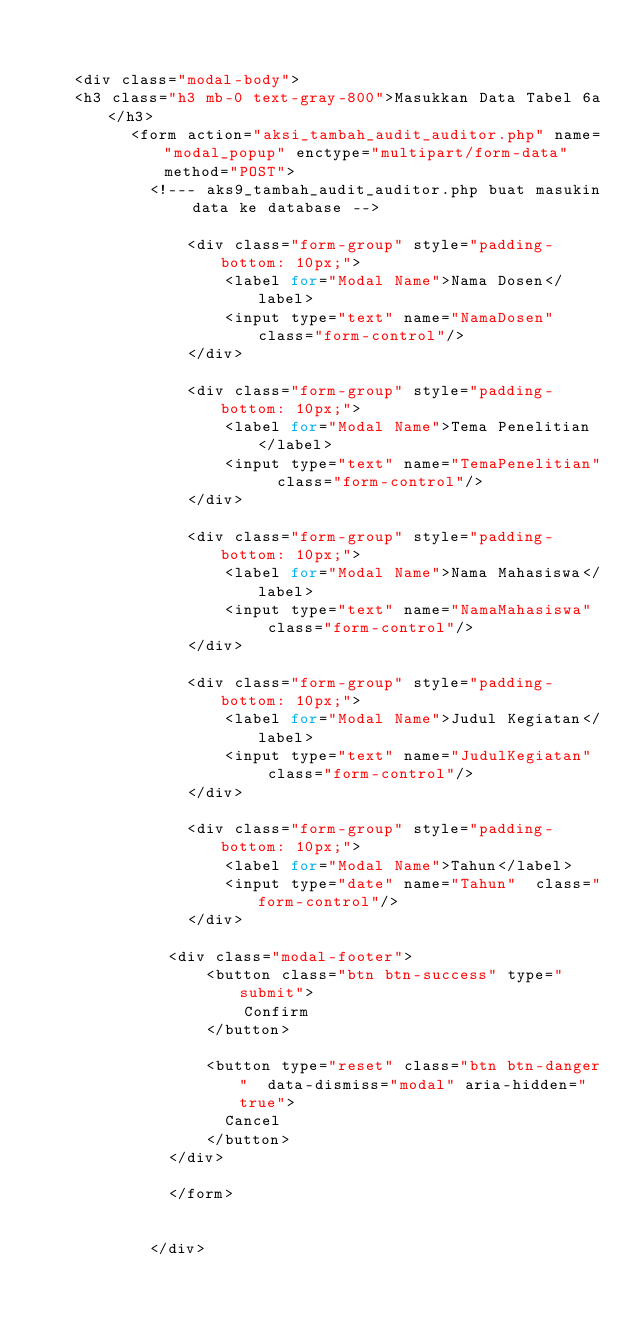<code> <loc_0><loc_0><loc_500><loc_500><_PHP_>    

    <div class="modal-body">
    <h3 class="h3 mb-0 text-gray-800">Masukkan Data Tabel 6a</h3>                        
          <form action="aksi_tambah_audit_auditor.php" name="modal_popup" enctype="multipart/form-data" method="POST">                                     
            <!--- aks9_tambah_audit_auditor.php buat masukin data ke database -->

                <div class="form-group" style="padding-bottom: 10px;">
                    <label for="Modal Name">Nama Dosen</label>
                    <input type="text" name="NamaDosen"  class="form-control"/>
                </div>  

                <div class="form-group" style="padding-bottom: 10px;">
                    <label for="Modal Name">Tema Penelitian</label>
                    <input type="text" name="TemaPenelitian"  class="form-control"/>
                </div>                

                <div class="form-group" style="padding-bottom: 10px;">
                    <label for="Modal Name">Nama Mahasiswa</label>
                    <input type="text" name="NamaMahasiswa"  class="form-control"/>
                </div>  

                <div class="form-group" style="padding-bottom: 10px;">
                    <label for="Modal Name">Judul Kegiatan</label>
                    <input type="text" name="JudulKegiatan"  class="form-control"/>
                </div> 

                <div class="form-group" style="padding-bottom: 10px;">
                    <label for="Modal Name">Tahun</label>
                    <input type="date" name="Tahun"  class="form-control"/>
                </div>                   
                            
              <div class="modal-footer">
                  <button class="btn btn-success" type="submit">
                      Confirm
                  </button>

                  <button type="reset" class="btn btn-danger"  data-dismiss="modal" aria-hidden="true">
                    Cancel
                  </button>
              </div>

              </form>

      
            </div></code> 